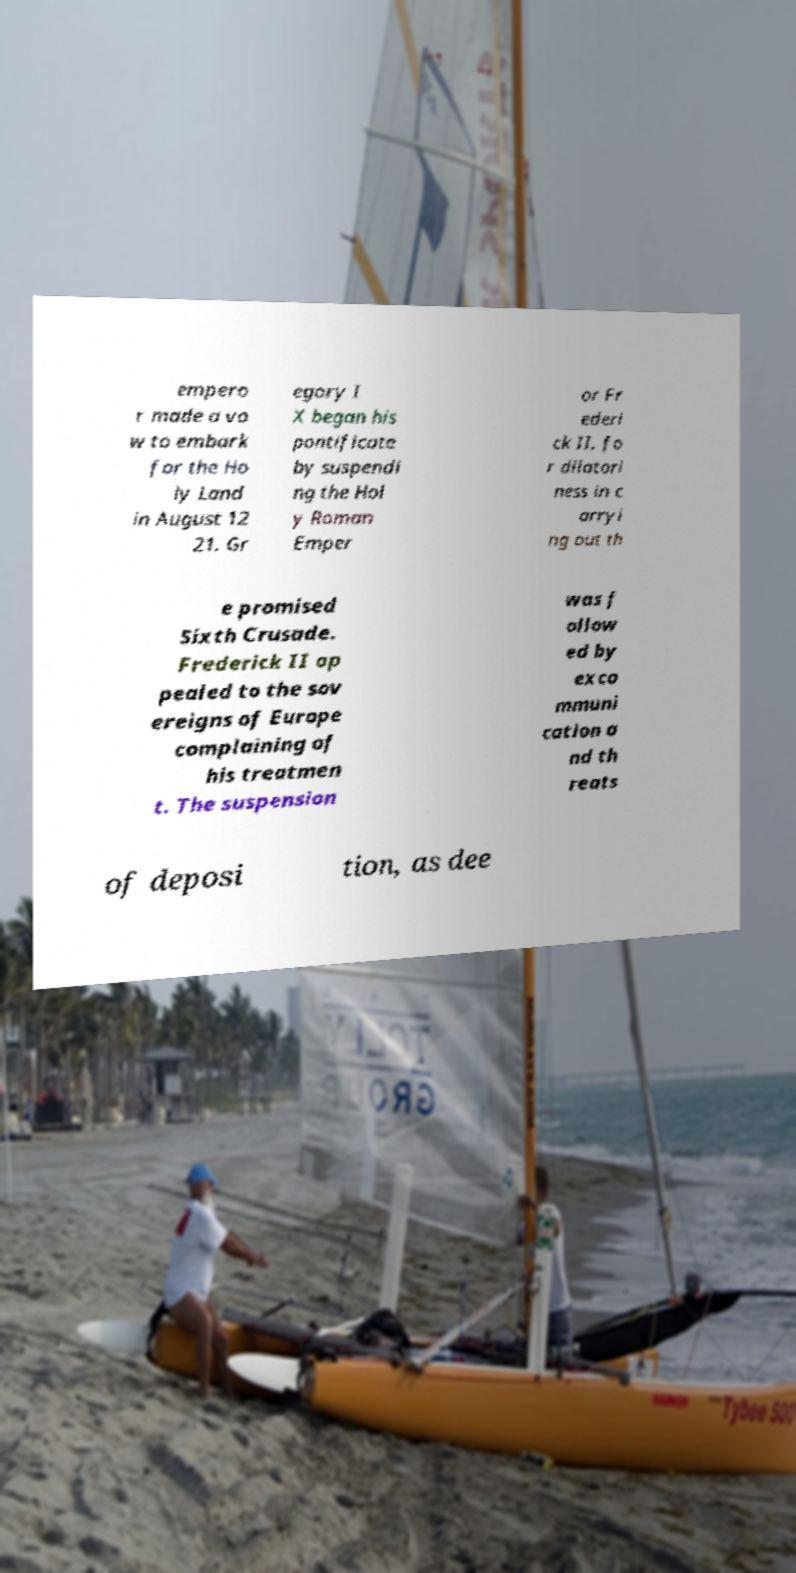There's text embedded in this image that I need extracted. Can you transcribe it verbatim? empero r made a vo w to embark for the Ho ly Land in August 12 21. Gr egory I X began his pontificate by suspendi ng the Hol y Roman Emper or Fr ederi ck II, fo r dilatori ness in c arryi ng out th e promised Sixth Crusade. Frederick II ap pealed to the sov ereigns of Europe complaining of his treatmen t. The suspension was f ollow ed by exco mmuni cation a nd th reats of deposi tion, as dee 